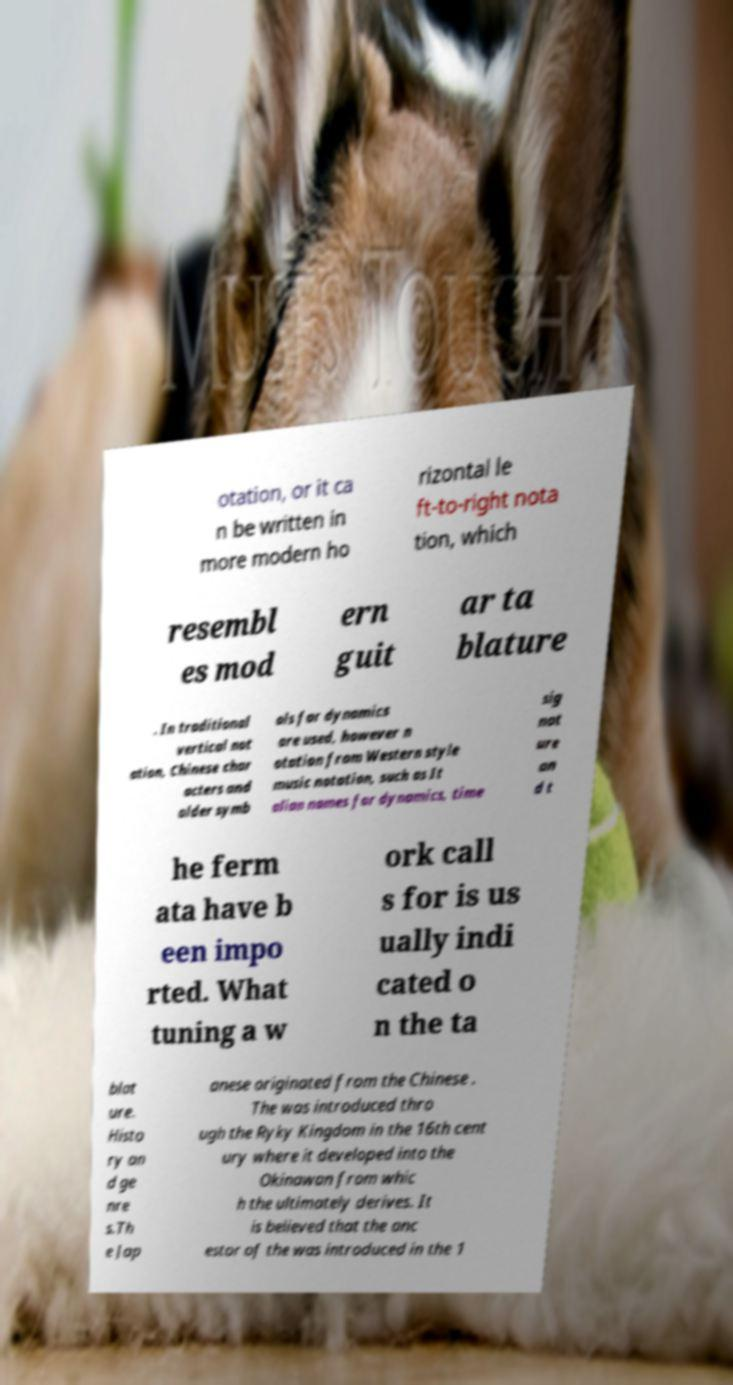There's text embedded in this image that I need extracted. Can you transcribe it verbatim? otation, or it ca n be written in more modern ho rizontal le ft-to-right nota tion, which resembl es mod ern guit ar ta blature . In traditional vertical not ation, Chinese char acters and older symb ols for dynamics are used, however n otation from Western style music notation, such as It alian names for dynamics, time sig nat ure an d t he ferm ata have b een impo rted. What tuning a w ork call s for is us ually indi cated o n the ta blat ure. Histo ry an d ge nre s.Th e Jap anese originated from the Chinese . The was introduced thro ugh the Ryky Kingdom in the 16th cent ury where it developed into the Okinawan from whic h the ultimately derives. It is believed that the anc estor of the was introduced in the 1 